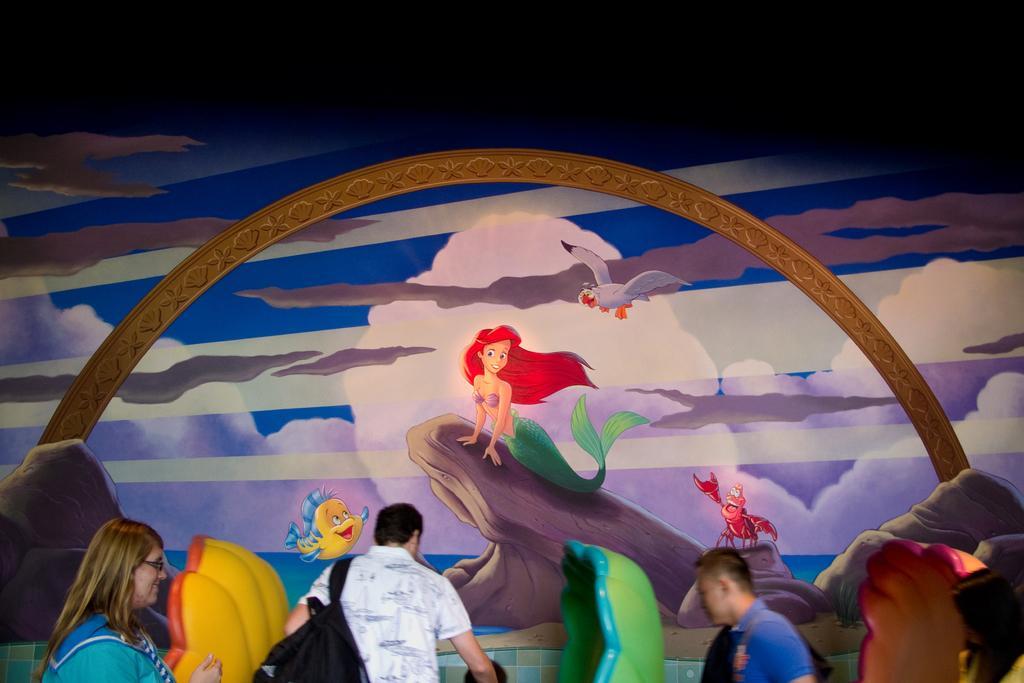Can you describe this image briefly? In this image we can see the people standing, in front of them we can see there are two objects. And we can see the wall with painting. 